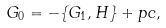Convert formula to latex. <formula><loc_0><loc_0><loc_500><loc_500>G _ { 0 } = - \{ G _ { 1 } , H \} + p c ,</formula> 